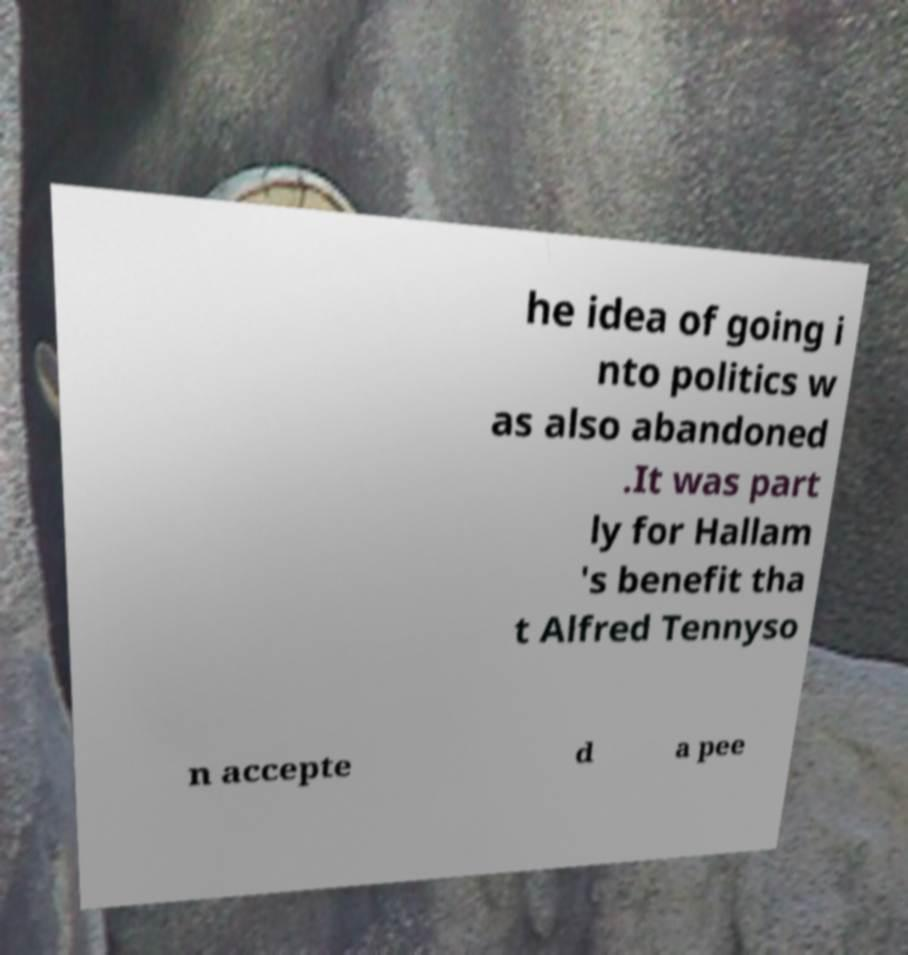Could you extract and type out the text from this image? he idea of going i nto politics w as also abandoned .It was part ly for Hallam 's benefit tha t Alfred Tennyso n accepte d a pee 